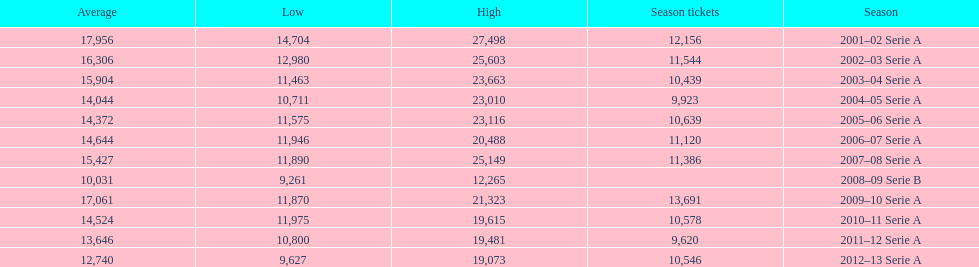How many seasons had average attendance of at least 15,000 at the stadio ennio tardini? 5. 